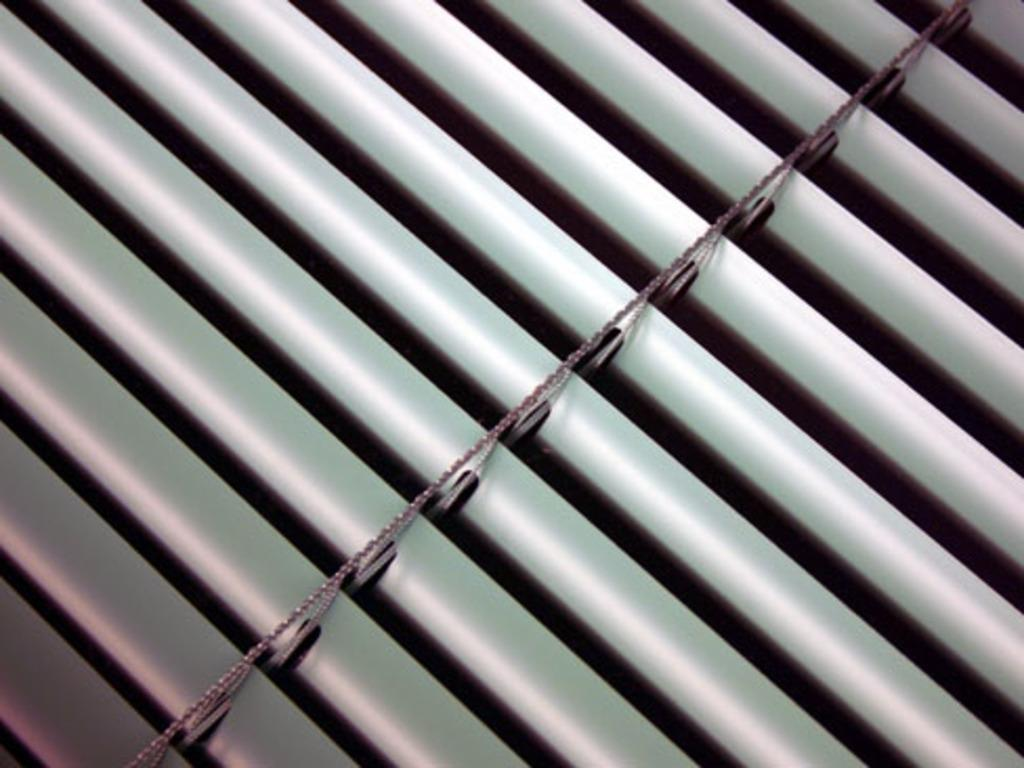What type of material is visible in the image? There are window sheets in the image. How does the window sheet gain knowledge in the image? Window sheets do not have the ability to gain knowledge, as they are inanimate objects. 